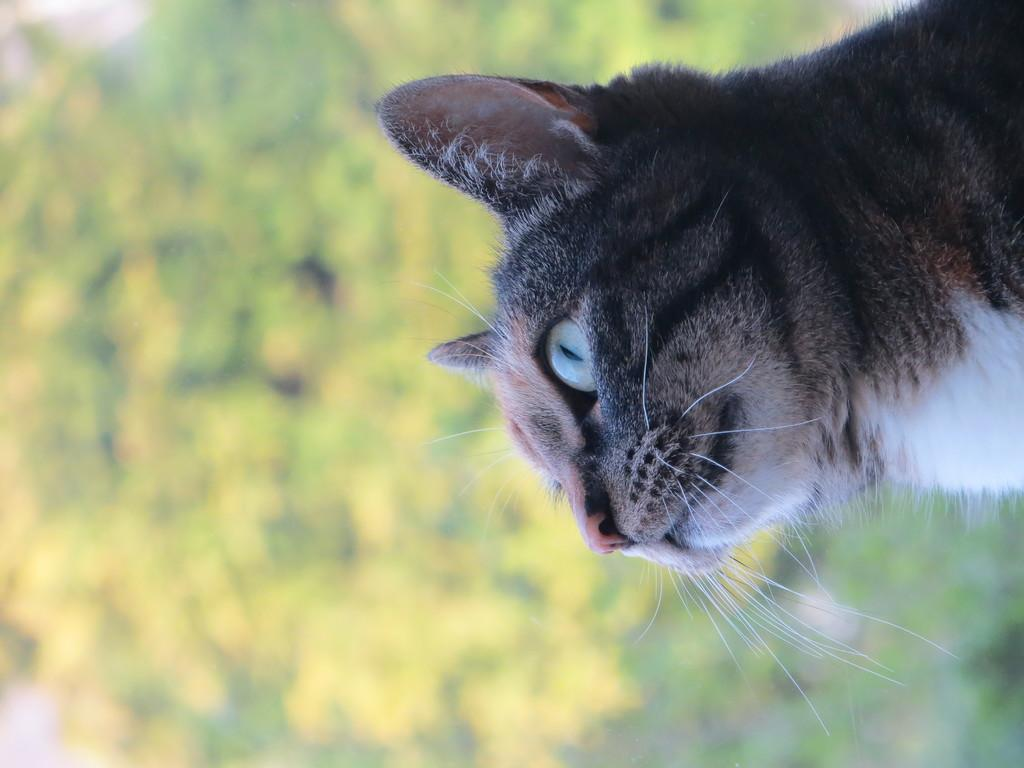What type of animal is in the image? There is a cat in the image. Can you describe the background of the image? The background of the image is blurred. What type of bead is the cat wearing in the image? There is no bead present in the image, and the cat is not wearing any accessories. 